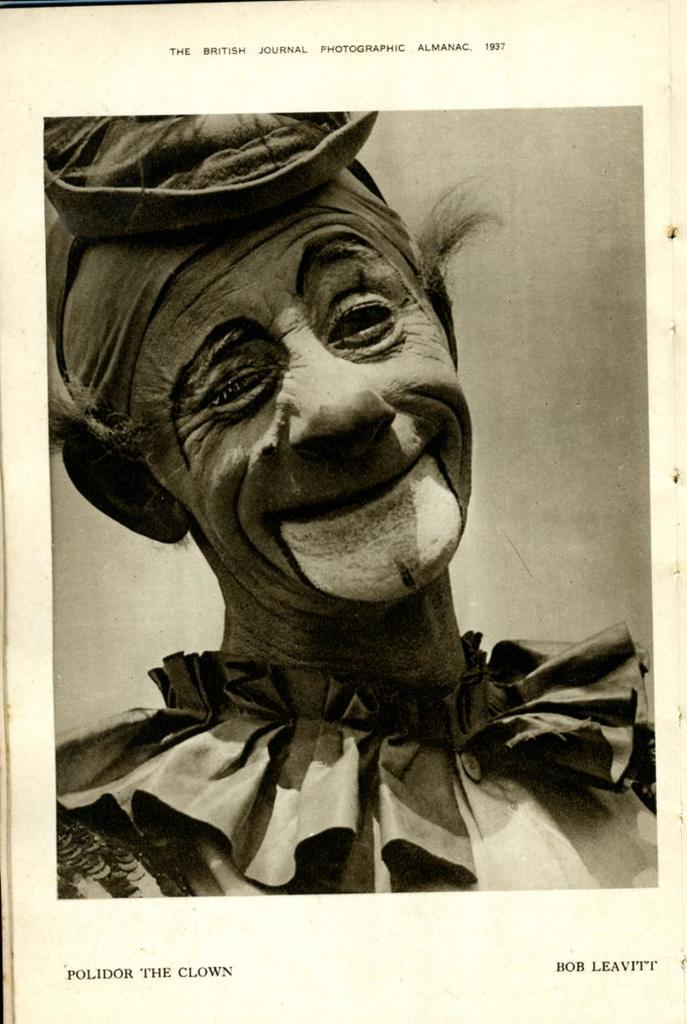What is the main subject of the image? There is a photo in the image. What can be seen in the photo? The photo contains a person. Are there any words or letters in the photo? Yes, there is text in the photo. What type of fork is being used to grab the attention of the person in the photo? There is no fork present in the image, and the person in the photo is not being grabbed by any object. 